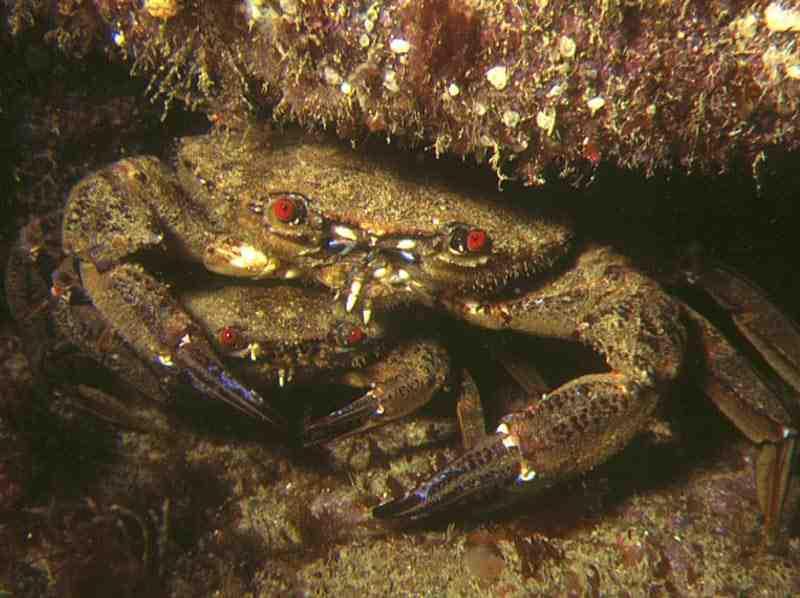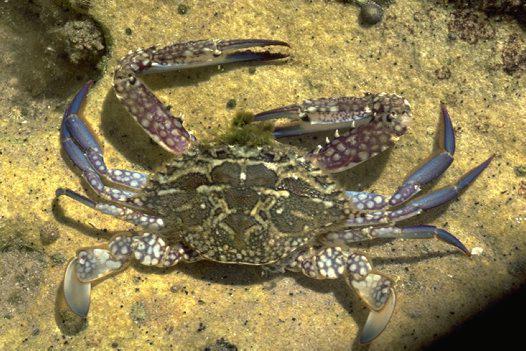The first image is the image on the left, the second image is the image on the right. Assess this claim about the two images: "Three pairs of eyes are visible.". Correct or not? Answer yes or no. No. 